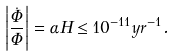<formula> <loc_0><loc_0><loc_500><loc_500>\left | \frac { \dot { \Phi } } { \Phi } \right | = \alpha H \leq 1 0 ^ { - 1 1 } y r ^ { - 1 } .</formula> 